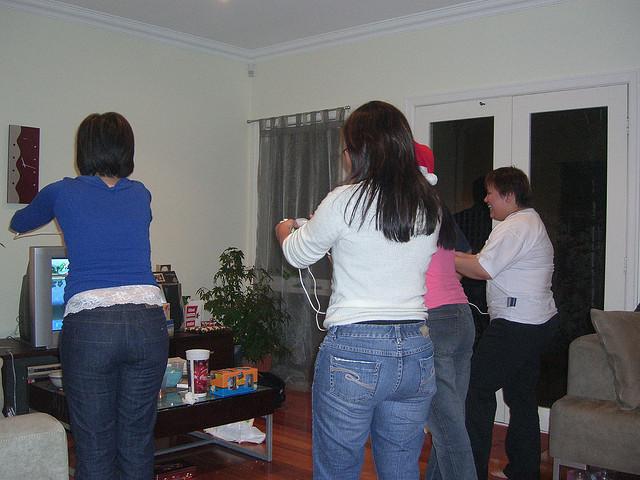Are they playing a group game?
Quick response, please. Yes. Is this in a home?
Short answer required. Yes. What room is this?
Short answer required. Living room. What game are these girls playing?
Quick response, please. Wii. How many people are there?
Quick response, please. 4. What type of pants are they wearing?
Be succinct. Jeans. 